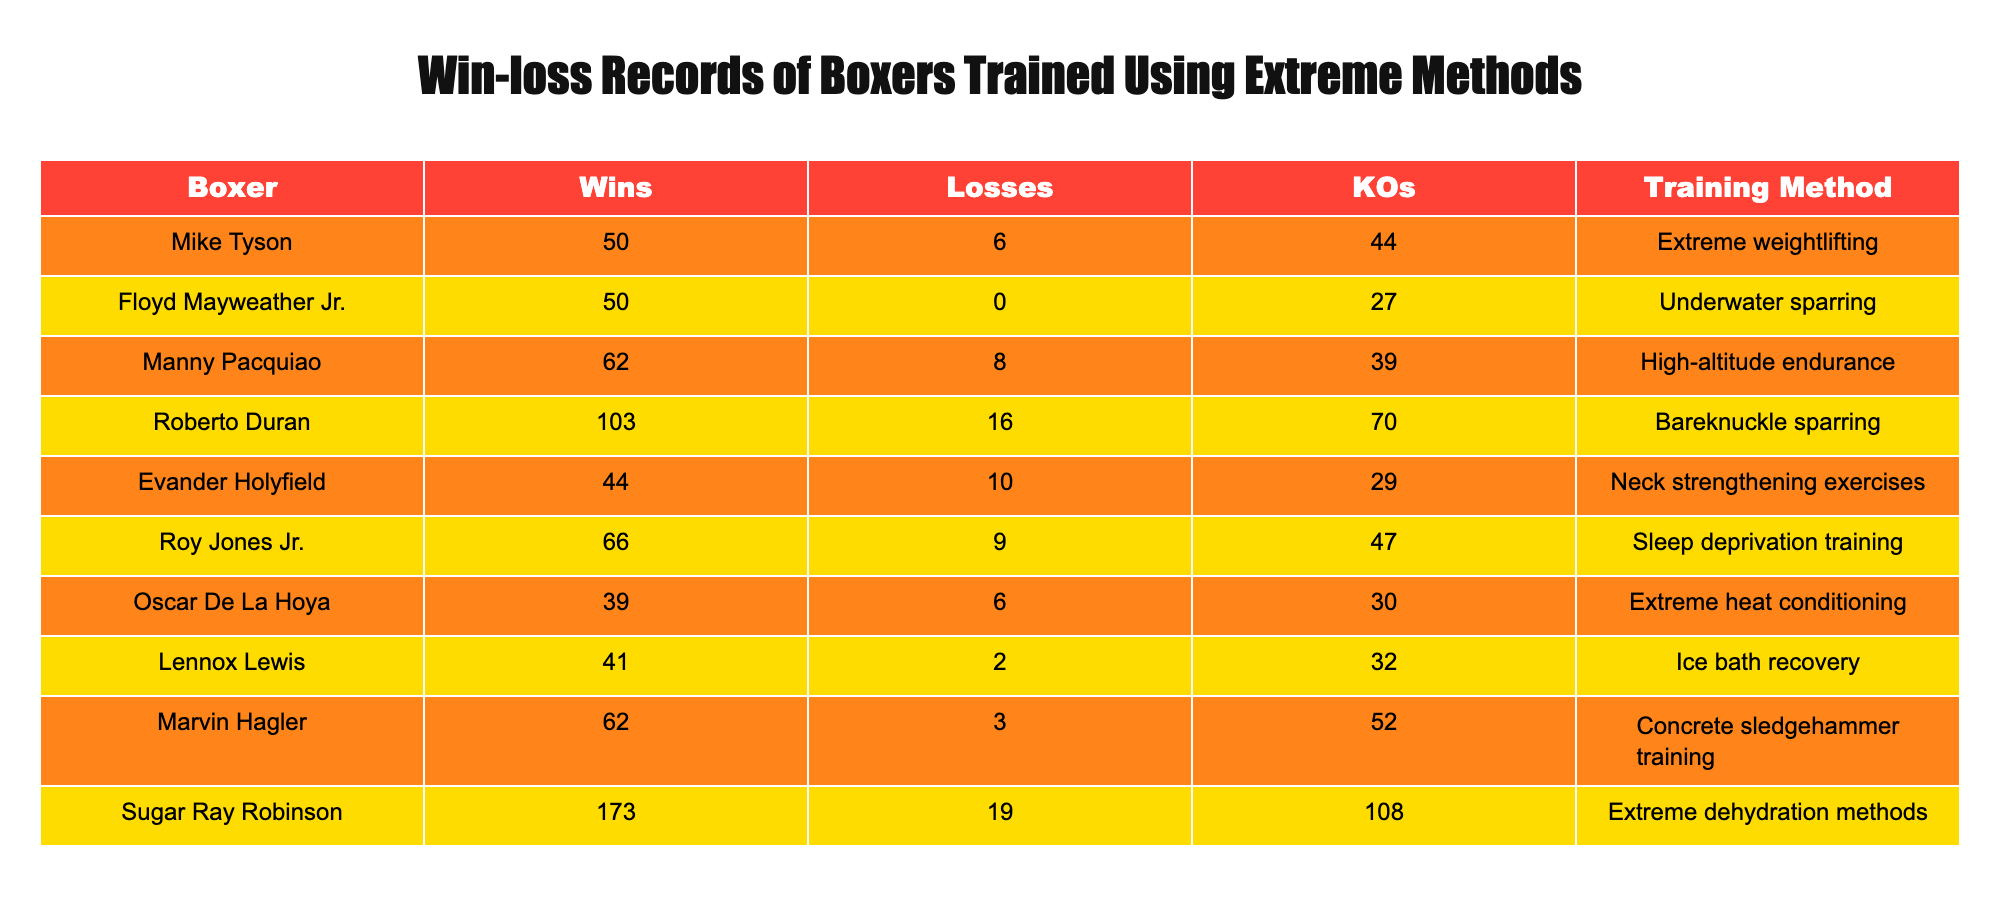What is the win-loss record of Oscar De La Hoya? Oscar De La Hoya has 39 wins and 6 losses. These values can be found directly in the corresponding row of the table.
Answer: 39 wins, 6 losses Which boxer has the most victories and how many KOs did they score? Sugar Ray Robinson has the most victories at 173 and scored 108 KOs, as shown in the table's last row.
Answer: 173 victories, 108 KOs Is there a boxer with zero losses, and if so, who? Yes, Floyd Mayweather Jr. has zero losses, clearly indicated in his row in the table.
Answer: Yes, Floyd Mayweather Jr What is the total number of KOs scored by boxers trained with extreme conditioning methods? To find this, we add the KOs for each boxer: 44 + 27 + 39 + 70 + 29 + 47 + 30 + 32 + 52 + 108 = 478. Thus, the total KOs is 478.
Answer: 478 KOs Which training method has the boxer with the highest number of losses, and what is that boxer's name? Roberto Duran has the highest number of losses, which is 16, and he trained using bareknuckle sparring as stated in the table.
Answer: Roberto Duran, Bareknuckle sparring What is the average number of wins among the boxers listed? To calculate the average, sum the wins: 50 + 50 + 62 + 103 + 44 + 66 + 39 + 41 + 62 + 173 = 636. Then divide by the number of boxers (10): 636/10 = 63.6.
Answer: 63.6 wins Do any boxers have fewer losses than KOs? Yes, Evander Holyfield has 10 losses and 29 KOs. We find this by examining the KOs and losses in his row.
Answer: Yes How many boxers have more wins than losses? Counting the boxers: Mike Tyson, Floyd Mayweather Jr., Manny Pacquiao, Roberto Duran, Roy Jones Jr., Marvin Hagler, Sugar Ray Robinson all have more wins than losses. In total, there are 7 boxers.
Answer: 7 boxers 